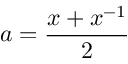Convert formula to latex. <formula><loc_0><loc_0><loc_500><loc_500>a = { \frac { x + x ^ { - 1 } } { 2 } }</formula> 